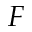Convert formula to latex. <formula><loc_0><loc_0><loc_500><loc_500>F</formula> 